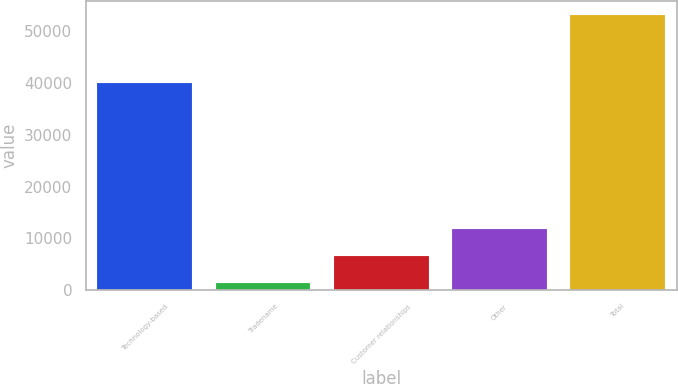Convert chart to OTSL. <chart><loc_0><loc_0><loc_500><loc_500><bar_chart><fcel>Technology-based<fcel>Tradename<fcel>Customer relationships<fcel>Other<fcel>Total<nl><fcel>39924<fcel>1478<fcel>6646.7<fcel>11815.4<fcel>53165<nl></chart> 